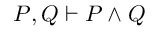<formula> <loc_0><loc_0><loc_500><loc_500>P , Q \vdash P \land Q</formula> 